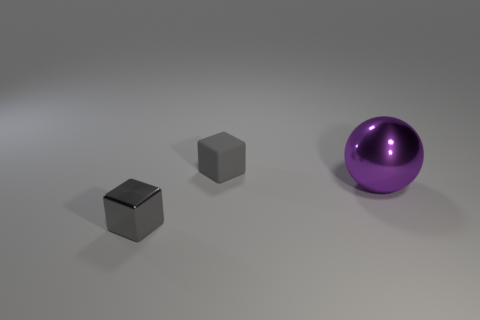Add 2 big metallic things. How many objects exist? 5 Subtract all spheres. How many objects are left? 2 Add 1 small gray things. How many small gray things are left? 3 Add 2 big spheres. How many big spheres exist? 3 Subtract 0 red cubes. How many objects are left? 3 Subtract all gray matte blocks. Subtract all small gray metal things. How many objects are left? 1 